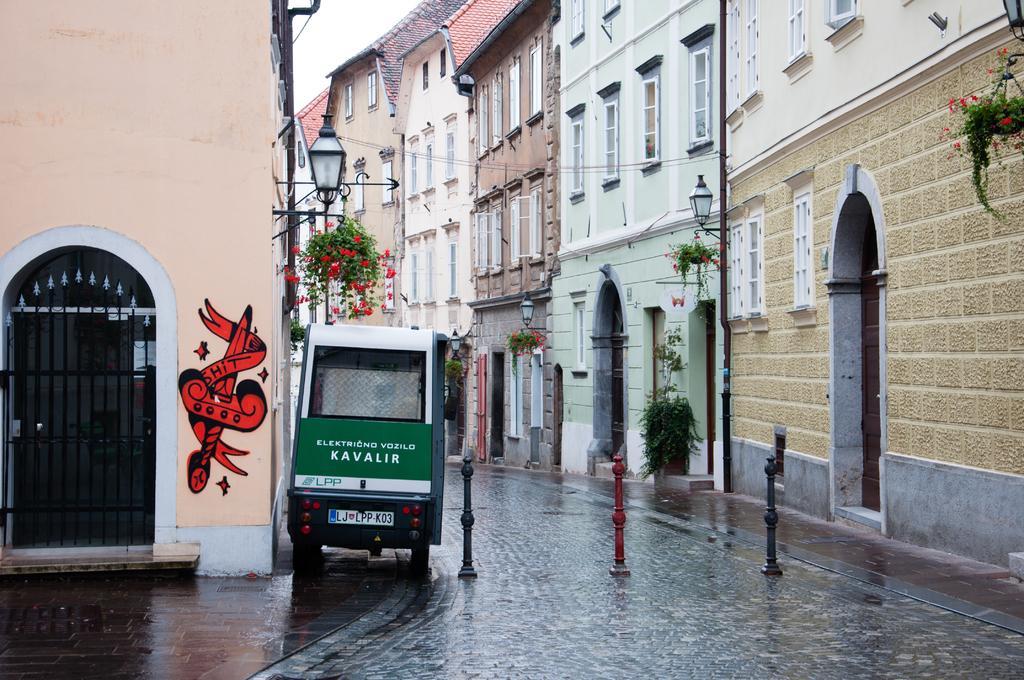Please provide a concise description of this image. In this picture we can observe a vehicle which is in green and white color on the road. We can observe three poles. There are some plants. On the left side we can observe a gate and a red color painting on the wall. In the background there are buildings and a sky. 